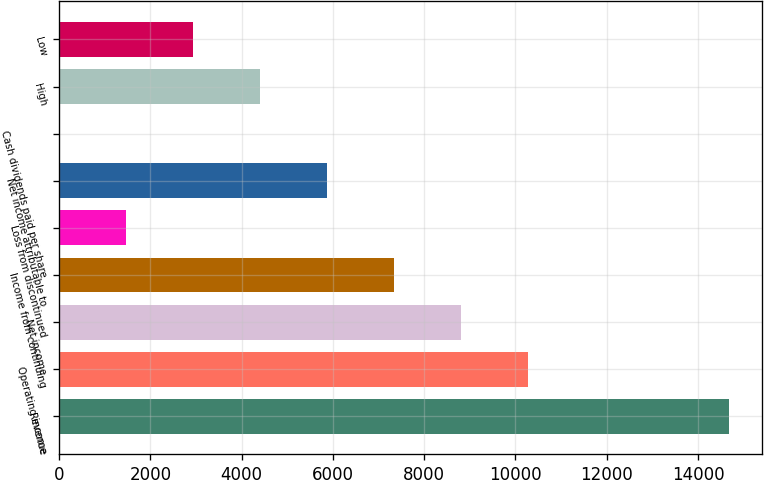Convert chart. <chart><loc_0><loc_0><loc_500><loc_500><bar_chart><fcel>Revenue<fcel>Operating income<fcel>Net income<fcel>Income from continuing<fcel>Loss from discontinued<fcel>Net income attributable to<fcel>Cash dividends paid per share<fcel>High<fcel>Low<nl><fcel>14675<fcel>10272.6<fcel>8805.12<fcel>7337.66<fcel>1467.82<fcel>5870.2<fcel>0.36<fcel>4402.74<fcel>2935.28<nl></chart> 